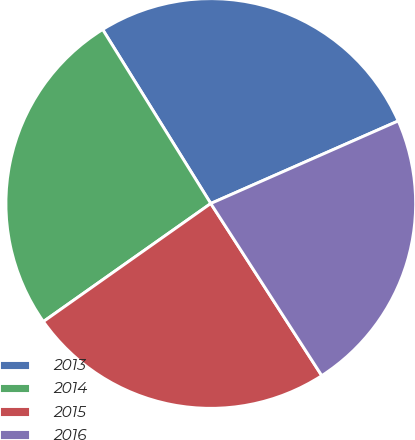<chart> <loc_0><loc_0><loc_500><loc_500><pie_chart><fcel>2013<fcel>2014<fcel>2015<fcel>2016<nl><fcel>27.25%<fcel>25.93%<fcel>24.34%<fcel>22.49%<nl></chart> 